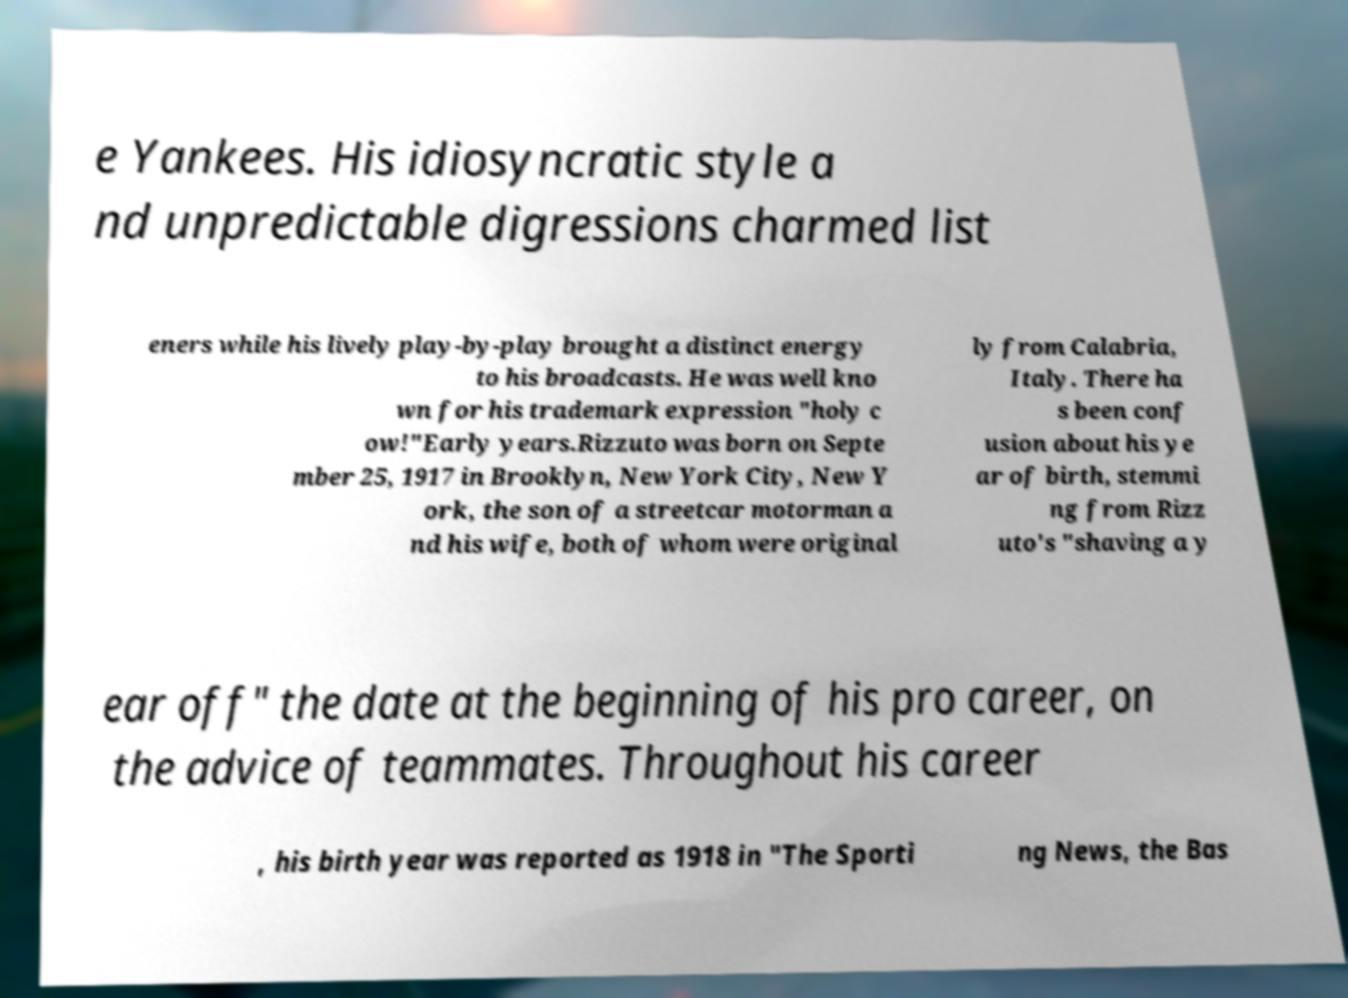What messages or text are displayed in this image? I need them in a readable, typed format. e Yankees. His idiosyncratic style a nd unpredictable digressions charmed list eners while his lively play-by-play brought a distinct energy to his broadcasts. He was well kno wn for his trademark expression "holy c ow!"Early years.Rizzuto was born on Septe mber 25, 1917 in Brooklyn, New York City, New Y ork, the son of a streetcar motorman a nd his wife, both of whom were original ly from Calabria, Italy. There ha s been conf usion about his ye ar of birth, stemmi ng from Rizz uto's "shaving a y ear off" the date at the beginning of his pro career, on the advice of teammates. Throughout his career , his birth year was reported as 1918 in "The Sporti ng News, the Bas 